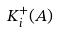Convert formula to latex. <formula><loc_0><loc_0><loc_500><loc_500>K _ { i } ^ { + } ( A )</formula> 